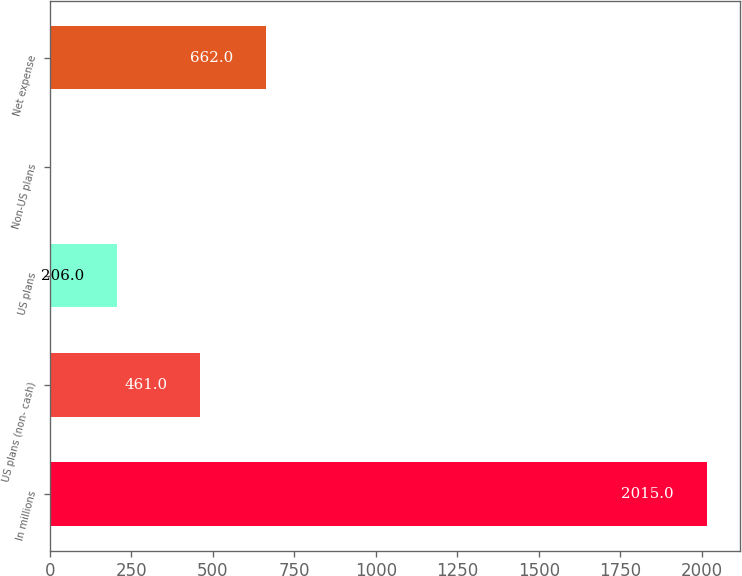<chart> <loc_0><loc_0><loc_500><loc_500><bar_chart><fcel>In millions<fcel>US plans (non- cash)<fcel>US plans<fcel>Non-US plans<fcel>Net expense<nl><fcel>2015<fcel>461<fcel>206<fcel>5<fcel>662<nl></chart> 